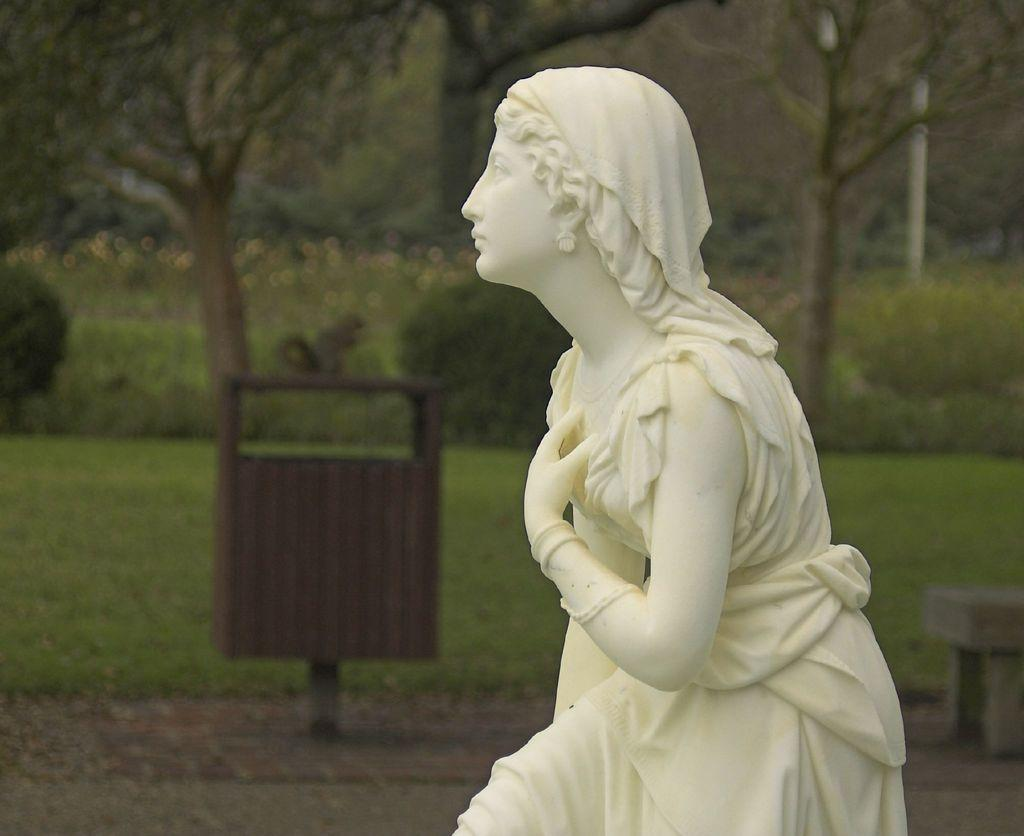What is the main subject in the image? There is a woman statue in the image. What other object can be seen in the image? There is a dustbin in the image. What is the ground covered with? The ground is covered with grass. What type of vegetation is present in the image? There are many trees in the image. How would you describe the background of the image? The background of the image is slightly blurred. What type of behavior does the minister exhibit in the image? There is no minister present in the image, so it is not possible to describe their behavior. 